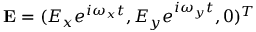Convert formula to latex. <formula><loc_0><loc_0><loc_500><loc_500>E = ( E _ { x } e ^ { i \omega _ { x } t } , E _ { y } e ^ { i \omega _ { y } t } , 0 ) ^ { T }</formula> 